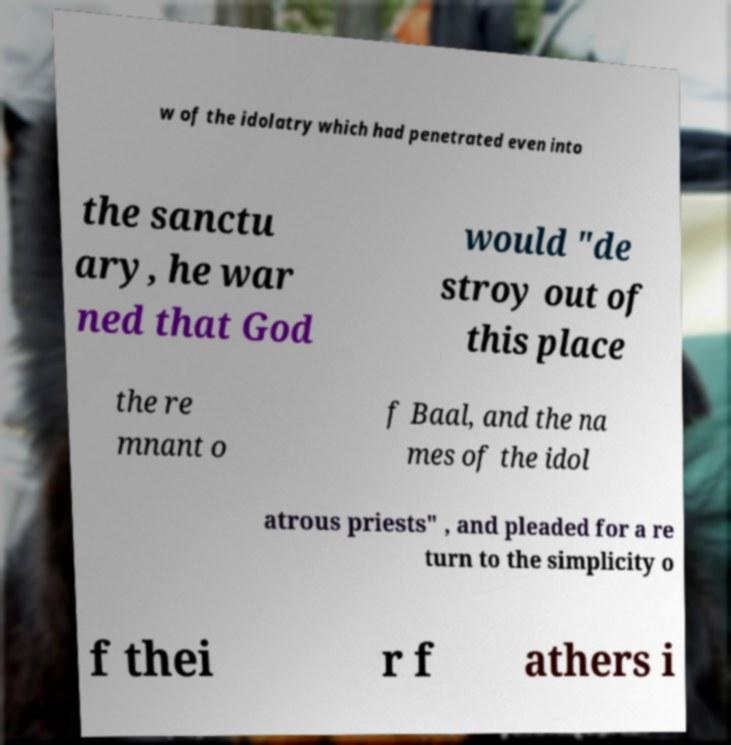Can you accurately transcribe the text from the provided image for me? w of the idolatry which had penetrated even into the sanctu ary, he war ned that God would "de stroy out of this place the re mnant o f Baal, and the na mes of the idol atrous priests" , and pleaded for a re turn to the simplicity o f thei r f athers i 